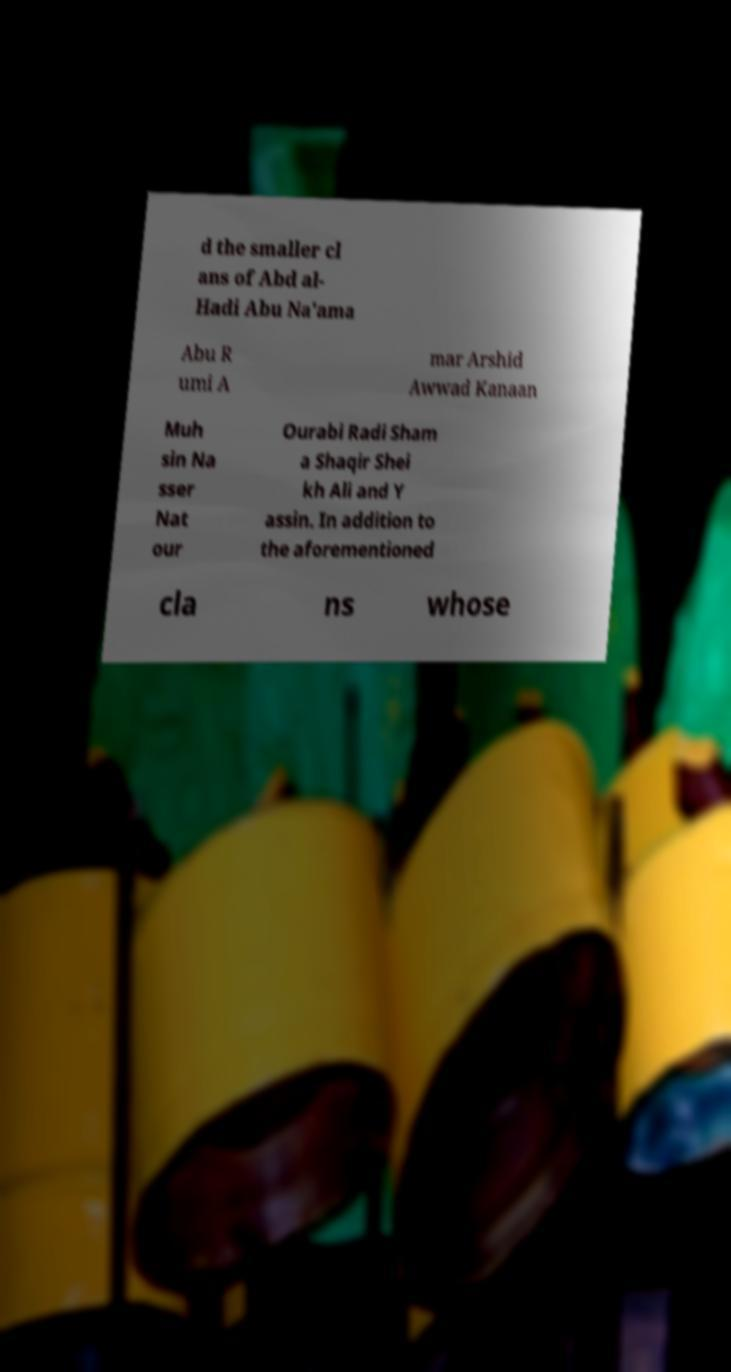What messages or text are displayed in this image? I need them in a readable, typed format. d the smaller cl ans of Abd al- Hadi Abu Na'ama Abu R umi A mar Arshid Awwad Kanaan Muh sin Na sser Nat our Ourabi Radi Sham a Shaqir Shei kh Ali and Y assin. In addition to the aforementioned cla ns whose 